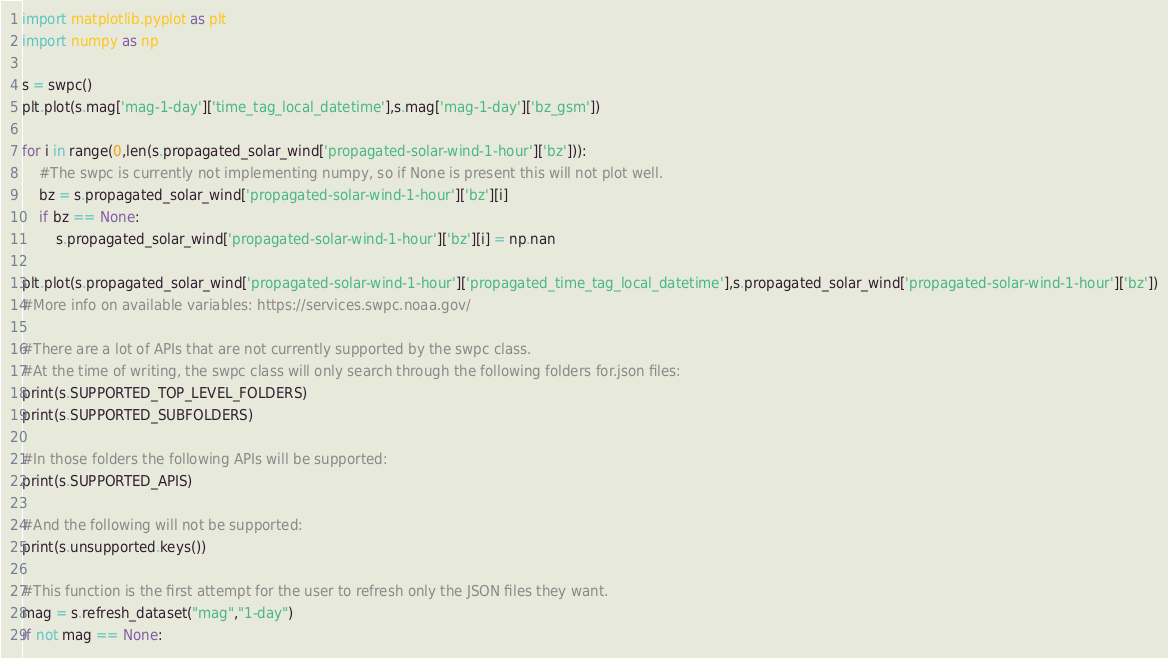Convert code to text. <code><loc_0><loc_0><loc_500><loc_500><_Python_>import matplotlib.pyplot as plt
import numpy as np

s = swpc()
plt.plot(s.mag['mag-1-day']['time_tag_local_datetime'],s.mag['mag-1-day']['bz_gsm'])

for i in range(0,len(s.propagated_solar_wind['propagated-solar-wind-1-hour']['bz'])):
    #The swpc is currently not implementing numpy, so if None is present this will not plot well.
    bz = s.propagated_solar_wind['propagated-solar-wind-1-hour']['bz'][i]
    if bz == None:
        s.propagated_solar_wind['propagated-solar-wind-1-hour']['bz'][i] = np.nan
        
plt.plot(s.propagated_solar_wind['propagated-solar-wind-1-hour']['propagated_time_tag_local_datetime'],s.propagated_solar_wind['propagated-solar-wind-1-hour']['bz'])
#More info on available variables: https://services.swpc.noaa.gov/

#There are a lot of APIs that are not currently supported by the swpc class.
#At the time of writing, the swpc class will only search through the following folders for.json files:
print(s.SUPPORTED_TOP_LEVEL_FOLDERS)
print(s.SUPPORTED_SUBFOLDERS)

#In those folders the following APIs will be supported:
print(s.SUPPORTED_APIS)

#And the following will not be supported:
print(s.unsupported.keys())

#This function is the first attempt for the user to refresh only the JSON files they want.
mag = s.refresh_dataset("mag","1-day")
if not mag == None:</code> 